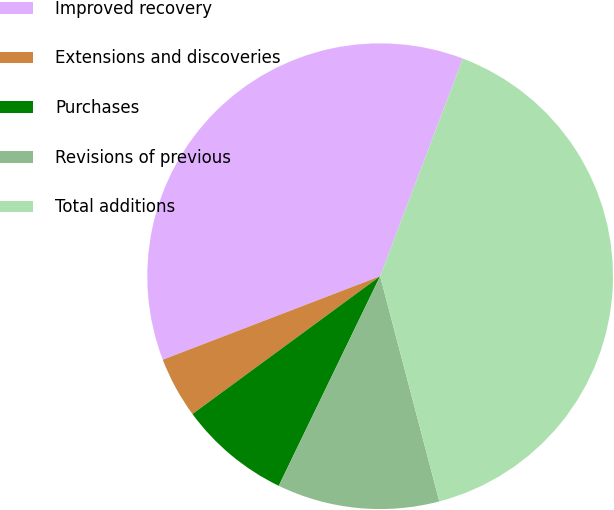Convert chart. <chart><loc_0><loc_0><loc_500><loc_500><pie_chart><fcel>Improved recovery<fcel>Extensions and discoveries<fcel>Purchases<fcel>Revisions of previous<fcel>Total additions<nl><fcel>36.62%<fcel>4.24%<fcel>7.75%<fcel>11.26%<fcel>40.13%<nl></chart> 